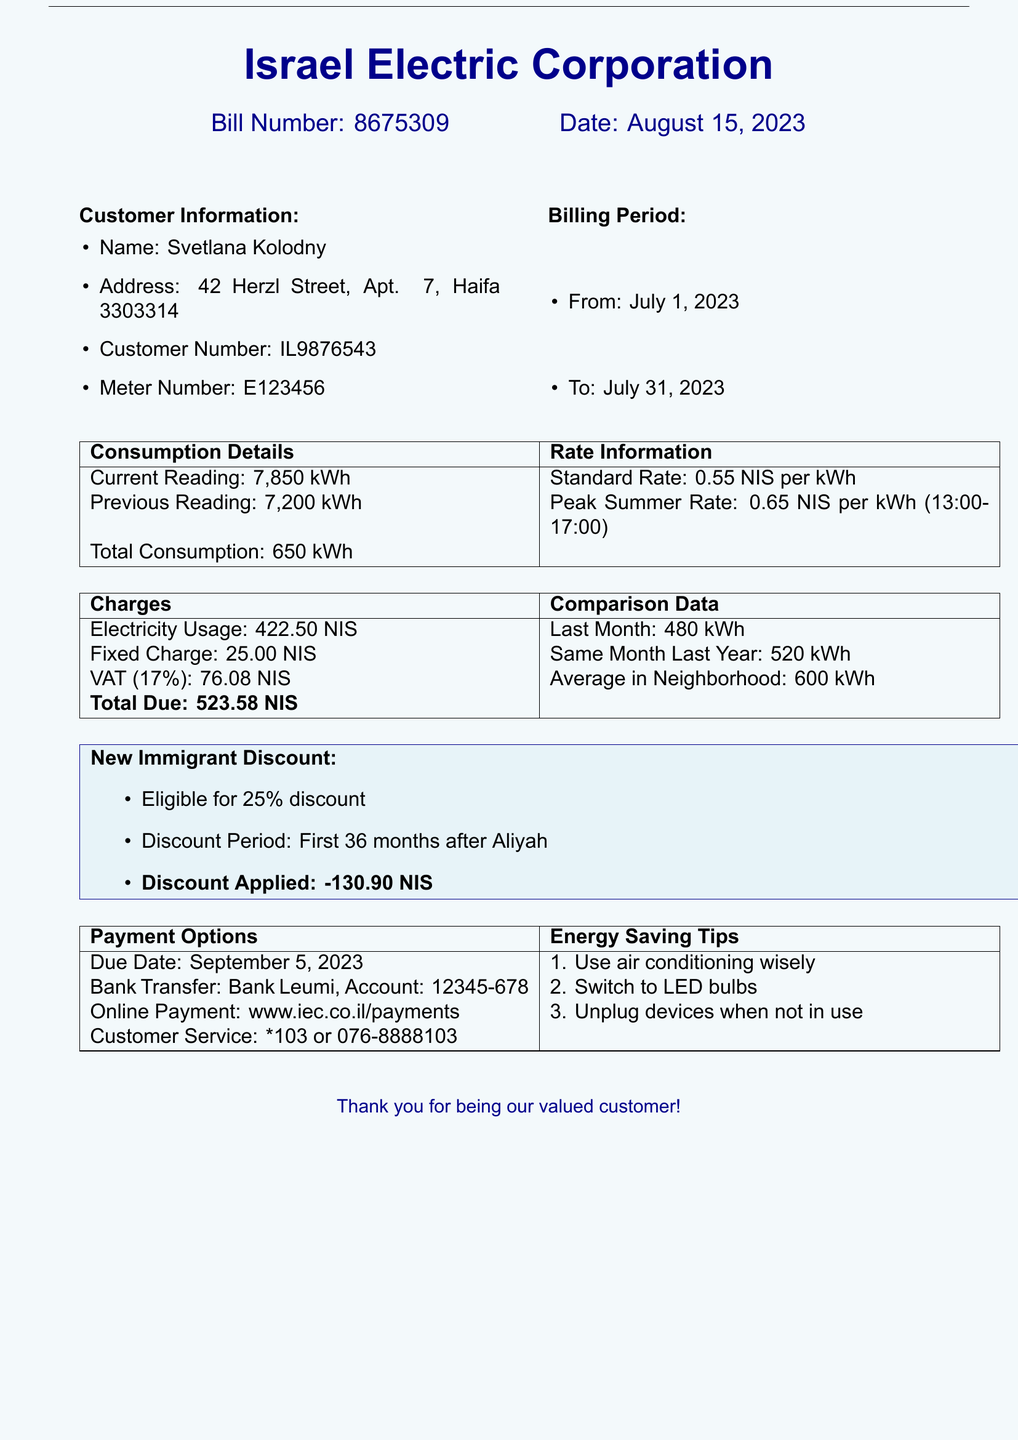What is the bill number? The bill number is specified at the top of the document.
Answer: 8675309 What is the total due amount? The total due amount is listed under the charges section.
Answer: 523.58 NIS What is the customer name? The customer's name is mentioned in the customer information section.
Answer: Svetlana Kolodny What is the standard rate per kWh? The standard rate is provided in the rate information section.
Answer: 0.55 NIS per kWh What was the total consumption for the billing period? Total consumption is detailed in the consumption details table.
Answer: 650 kWh What is the due date for the payment? The due date for the payment is indicated at the bottom of the document.
Answer: September 5, 2023 How much is the new immigrant discount? The discount amount is specified under the new immigrant discount section.
Answer: 130.90 NIS What is the previous reading? The previous reading is mentioned in the consumption details section.
Answer: 7200 kWh What was the average consumption in the neighborhood? The average consumption is compared in the charges section.
Answer: 600 kWh 